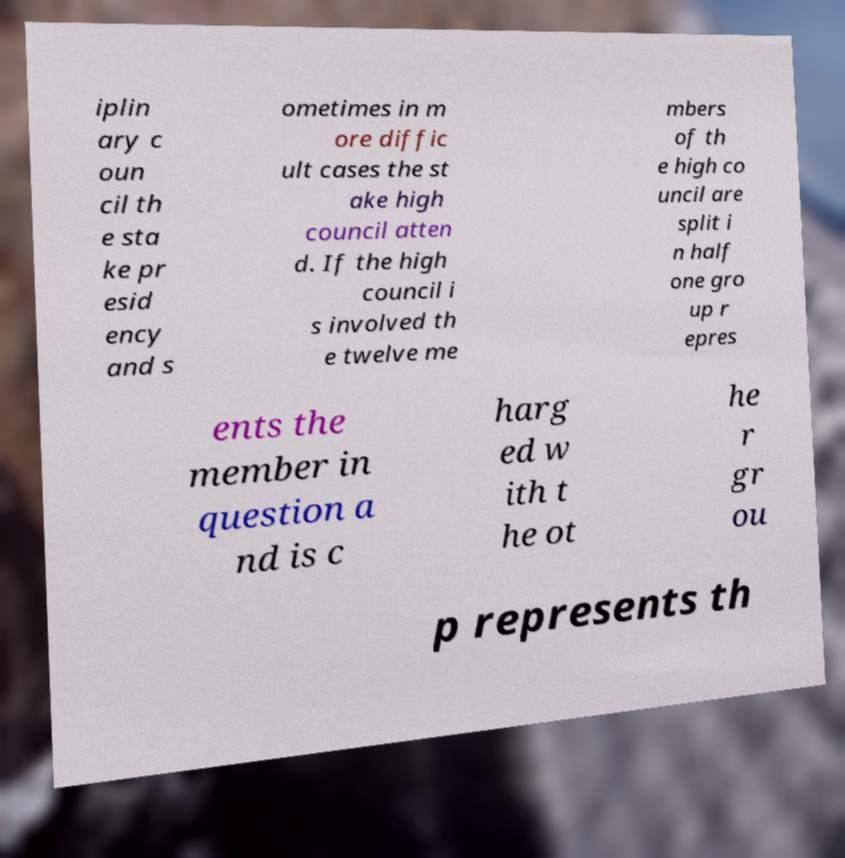Please identify and transcribe the text found in this image. iplin ary c oun cil th e sta ke pr esid ency and s ometimes in m ore diffic ult cases the st ake high council atten d. If the high council i s involved th e twelve me mbers of th e high co uncil are split i n half one gro up r epres ents the member in question a nd is c harg ed w ith t he ot he r gr ou p represents th 